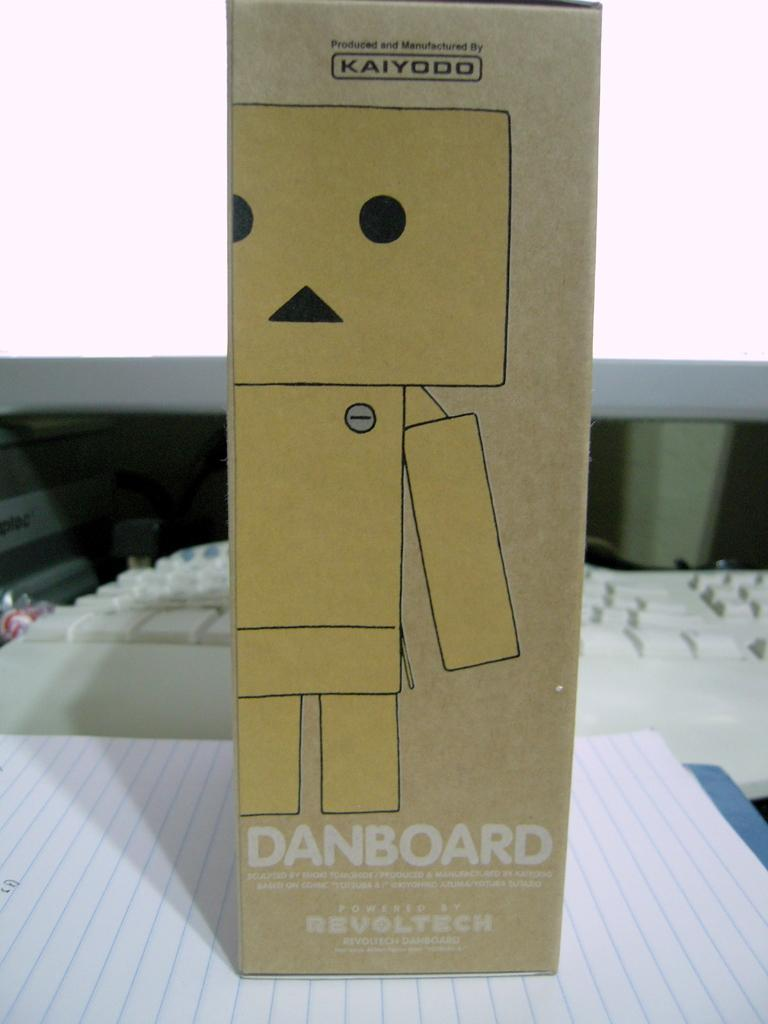<image>
Share a concise interpretation of the image provided. the word danboard is on the brown box 